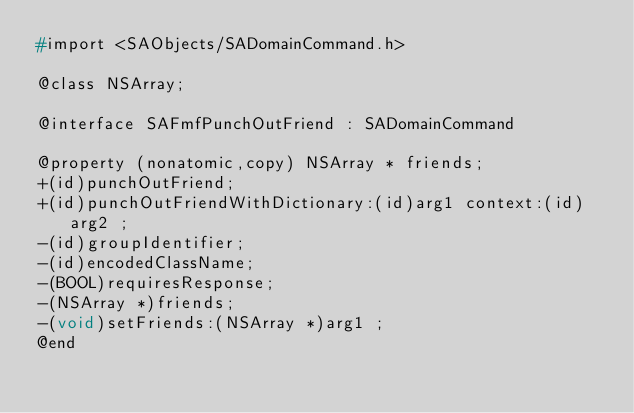Convert code to text. <code><loc_0><loc_0><loc_500><loc_500><_C_>#import <SAObjects/SADomainCommand.h>

@class NSArray;

@interface SAFmfPunchOutFriend : SADomainCommand

@property (nonatomic,copy) NSArray * friends; 
+(id)punchOutFriend;
+(id)punchOutFriendWithDictionary:(id)arg1 context:(id)arg2 ;
-(id)groupIdentifier;
-(id)encodedClassName;
-(BOOL)requiresResponse;
-(NSArray *)friends;
-(void)setFriends:(NSArray *)arg1 ;
@end

</code> 